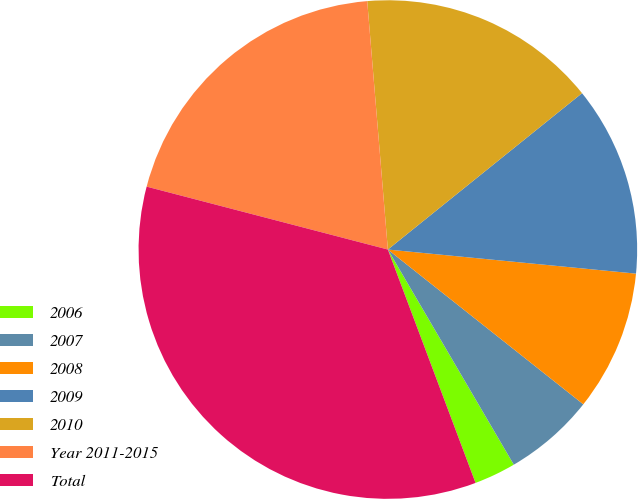Convert chart. <chart><loc_0><loc_0><loc_500><loc_500><pie_chart><fcel>2006<fcel>2007<fcel>2008<fcel>2009<fcel>2010<fcel>Year 2011-2015<fcel>Total<nl><fcel>2.71%<fcel>5.91%<fcel>9.12%<fcel>12.33%<fcel>15.53%<fcel>19.62%<fcel>34.78%<nl></chart> 